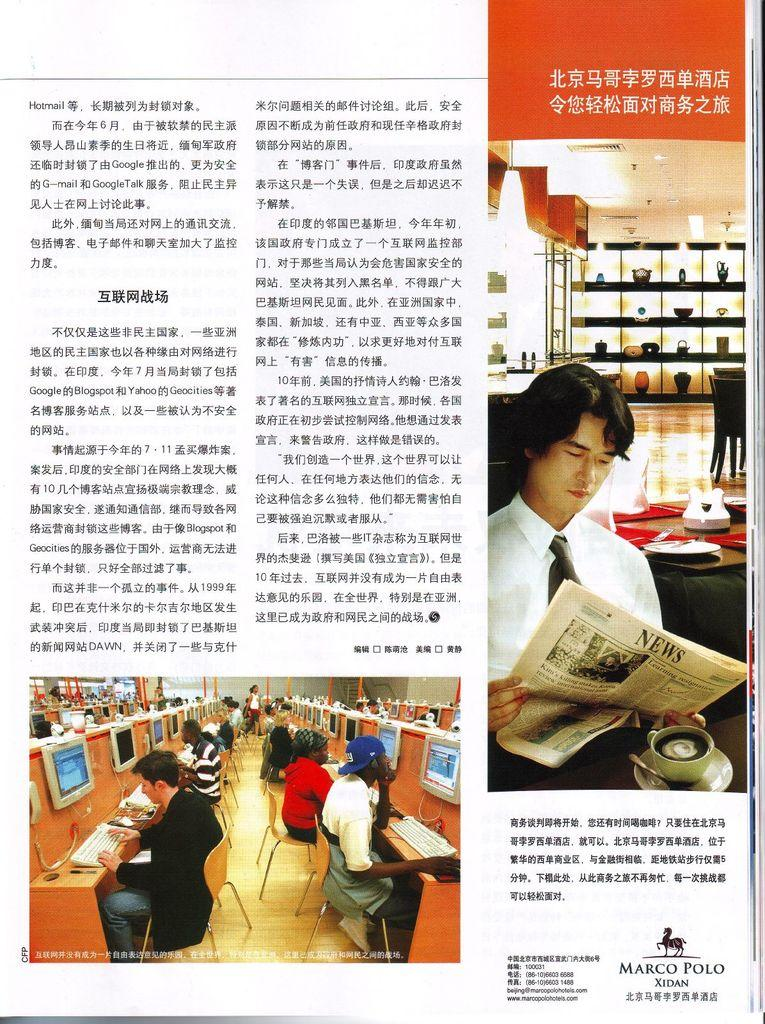<image>
Summarize the visual content of the image. Marco Polo Xidan is a company that produces Chinese magazine news articles. 